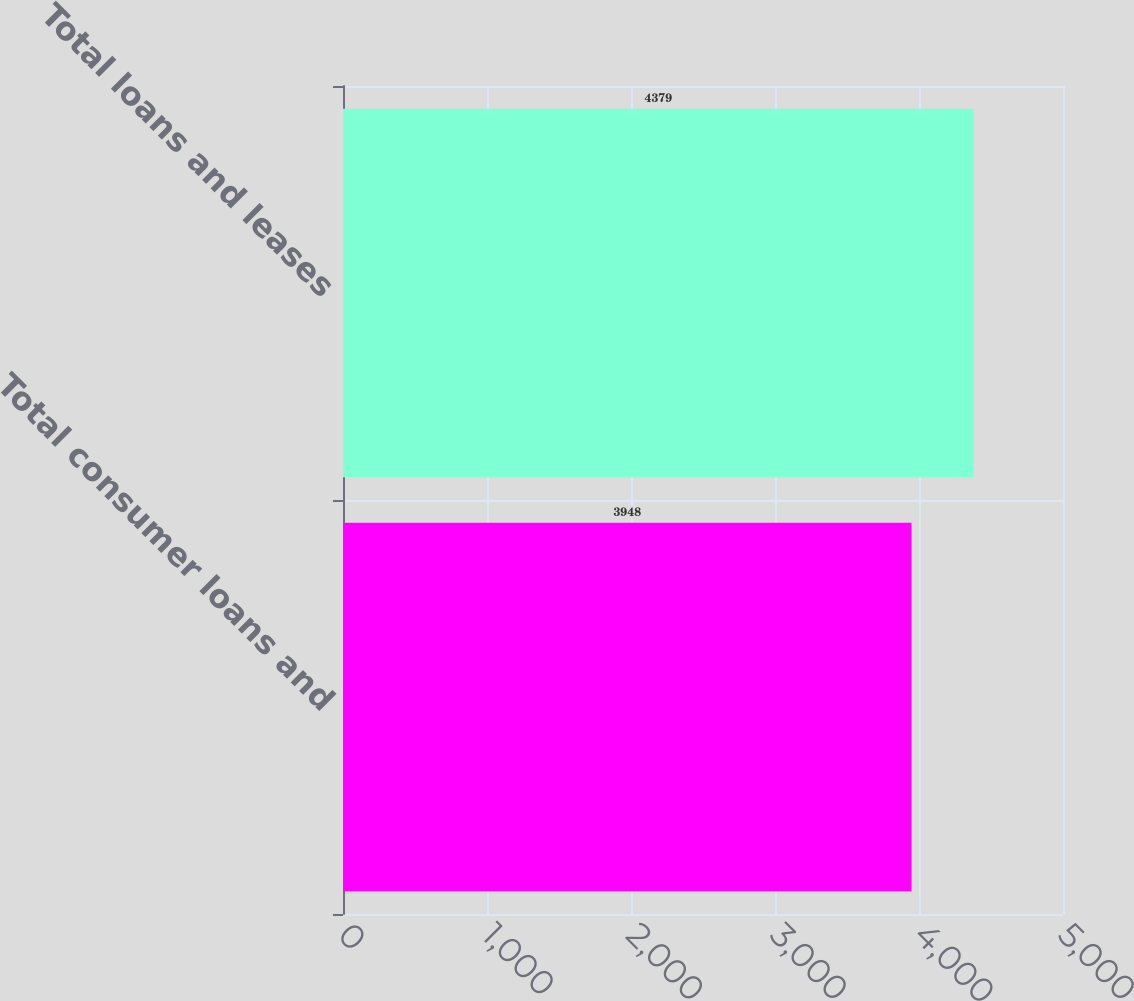<chart> <loc_0><loc_0><loc_500><loc_500><bar_chart><fcel>Total consumer loans and<fcel>Total loans and leases<nl><fcel>3948<fcel>4379<nl></chart> 